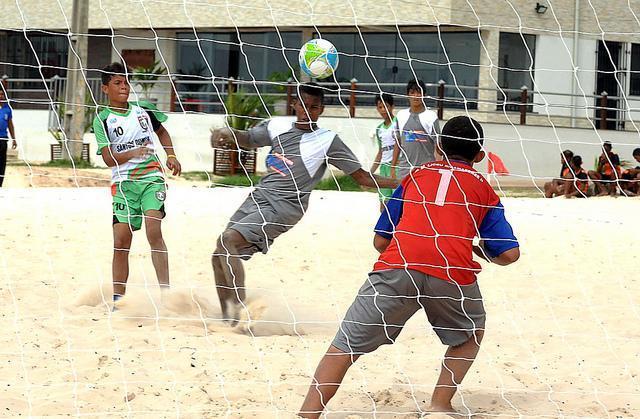How many people are in the photo?
Give a very brief answer. 4. 